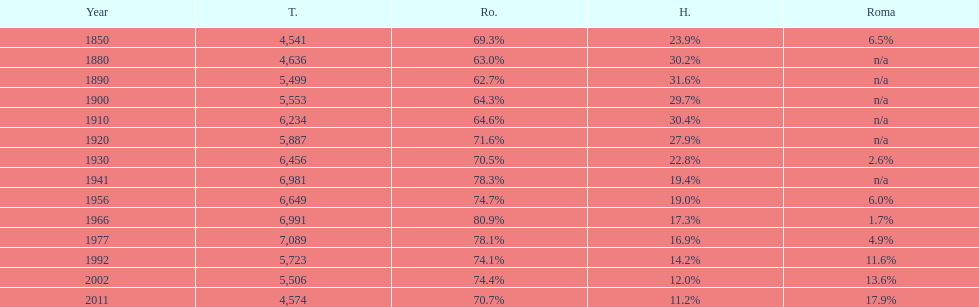Which year had the top percentage in romanian population? 1966. 